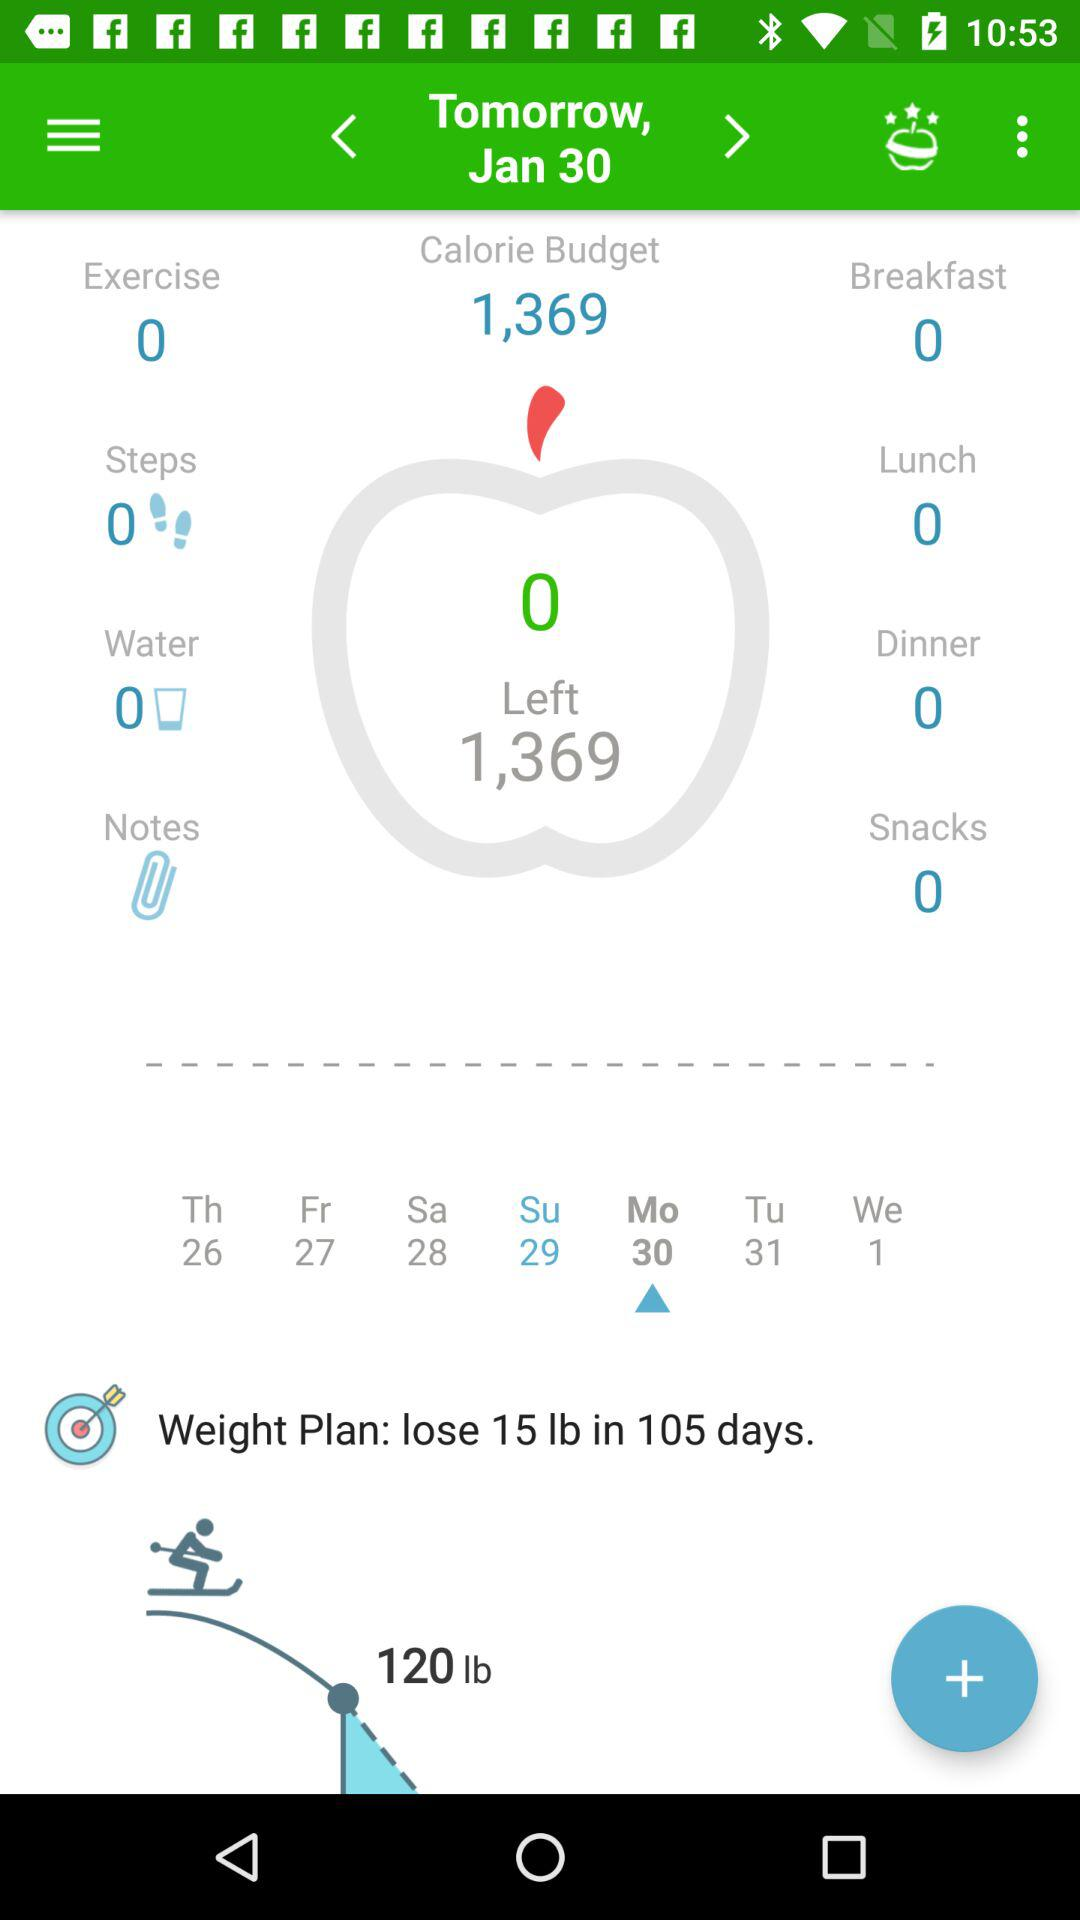How many calories have I eaten so far today?
Answer the question using a single word or phrase. 0 